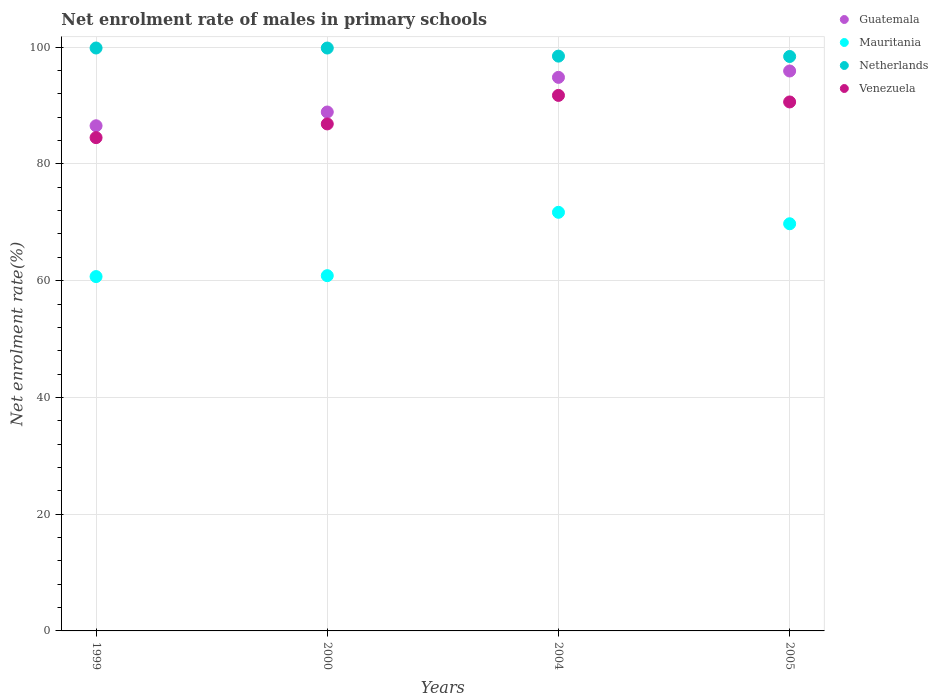What is the net enrolment rate of males in primary schools in Mauritania in 2004?
Ensure brevity in your answer.  71.71. Across all years, what is the maximum net enrolment rate of males in primary schools in Netherlands?
Ensure brevity in your answer.  99.86. Across all years, what is the minimum net enrolment rate of males in primary schools in Mauritania?
Your answer should be very brief. 60.7. In which year was the net enrolment rate of males in primary schools in Netherlands minimum?
Your answer should be very brief. 2005. What is the total net enrolment rate of males in primary schools in Netherlands in the graph?
Give a very brief answer. 396.6. What is the difference between the net enrolment rate of males in primary schools in Mauritania in 2000 and that in 2005?
Your answer should be very brief. -8.89. What is the difference between the net enrolment rate of males in primary schools in Netherlands in 2004 and the net enrolment rate of males in primary schools in Guatemala in 2000?
Provide a short and direct response. 9.57. What is the average net enrolment rate of males in primary schools in Netherlands per year?
Offer a very short reply. 99.15. In the year 2004, what is the difference between the net enrolment rate of males in primary schools in Guatemala and net enrolment rate of males in primary schools in Venezuela?
Keep it short and to the point. 3.09. What is the ratio of the net enrolment rate of males in primary schools in Mauritania in 1999 to that in 2000?
Your answer should be compact. 1. Is the difference between the net enrolment rate of males in primary schools in Guatemala in 2000 and 2005 greater than the difference between the net enrolment rate of males in primary schools in Venezuela in 2000 and 2005?
Give a very brief answer. No. What is the difference between the highest and the second highest net enrolment rate of males in primary schools in Mauritania?
Make the answer very short. 1.96. What is the difference between the highest and the lowest net enrolment rate of males in primary schools in Mauritania?
Make the answer very short. 11.01. In how many years, is the net enrolment rate of males in primary schools in Venezuela greater than the average net enrolment rate of males in primary schools in Venezuela taken over all years?
Make the answer very short. 2. Is the sum of the net enrolment rate of males in primary schools in Guatemala in 2004 and 2005 greater than the maximum net enrolment rate of males in primary schools in Venezuela across all years?
Your answer should be very brief. Yes. Is it the case that in every year, the sum of the net enrolment rate of males in primary schools in Venezuela and net enrolment rate of males in primary schools in Guatemala  is greater than the net enrolment rate of males in primary schools in Netherlands?
Offer a terse response. Yes. Is the net enrolment rate of males in primary schools in Netherlands strictly greater than the net enrolment rate of males in primary schools in Guatemala over the years?
Give a very brief answer. Yes. How many dotlines are there?
Make the answer very short. 4. What is the difference between two consecutive major ticks on the Y-axis?
Keep it short and to the point. 20. Does the graph contain any zero values?
Keep it short and to the point. No. Where does the legend appear in the graph?
Your answer should be compact. Top right. What is the title of the graph?
Provide a short and direct response. Net enrolment rate of males in primary schools. Does "High income: OECD" appear as one of the legend labels in the graph?
Provide a succinct answer. No. What is the label or title of the X-axis?
Your response must be concise. Years. What is the label or title of the Y-axis?
Your answer should be compact. Net enrolment rate(%). What is the Net enrolment rate(%) in Guatemala in 1999?
Your answer should be very brief. 86.54. What is the Net enrolment rate(%) in Mauritania in 1999?
Provide a short and direct response. 60.7. What is the Net enrolment rate(%) in Netherlands in 1999?
Your answer should be very brief. 99.86. What is the Net enrolment rate(%) in Venezuela in 1999?
Keep it short and to the point. 84.51. What is the Net enrolment rate(%) of Guatemala in 2000?
Provide a succinct answer. 88.9. What is the Net enrolment rate(%) of Mauritania in 2000?
Offer a terse response. 60.86. What is the Net enrolment rate(%) in Netherlands in 2000?
Offer a terse response. 99.86. What is the Net enrolment rate(%) of Venezuela in 2000?
Provide a short and direct response. 86.85. What is the Net enrolment rate(%) in Guatemala in 2004?
Your answer should be compact. 94.83. What is the Net enrolment rate(%) of Mauritania in 2004?
Provide a succinct answer. 71.71. What is the Net enrolment rate(%) of Netherlands in 2004?
Ensure brevity in your answer.  98.47. What is the Net enrolment rate(%) of Venezuela in 2004?
Keep it short and to the point. 91.74. What is the Net enrolment rate(%) of Guatemala in 2005?
Keep it short and to the point. 95.92. What is the Net enrolment rate(%) in Mauritania in 2005?
Provide a short and direct response. 69.75. What is the Net enrolment rate(%) in Netherlands in 2005?
Provide a succinct answer. 98.41. What is the Net enrolment rate(%) of Venezuela in 2005?
Offer a terse response. 90.62. Across all years, what is the maximum Net enrolment rate(%) of Guatemala?
Keep it short and to the point. 95.92. Across all years, what is the maximum Net enrolment rate(%) in Mauritania?
Make the answer very short. 71.71. Across all years, what is the maximum Net enrolment rate(%) in Netherlands?
Ensure brevity in your answer.  99.86. Across all years, what is the maximum Net enrolment rate(%) of Venezuela?
Offer a terse response. 91.74. Across all years, what is the minimum Net enrolment rate(%) in Guatemala?
Give a very brief answer. 86.54. Across all years, what is the minimum Net enrolment rate(%) of Mauritania?
Offer a very short reply. 60.7. Across all years, what is the minimum Net enrolment rate(%) of Netherlands?
Provide a succinct answer. 98.41. Across all years, what is the minimum Net enrolment rate(%) in Venezuela?
Provide a short and direct response. 84.51. What is the total Net enrolment rate(%) of Guatemala in the graph?
Provide a short and direct response. 366.19. What is the total Net enrolment rate(%) of Mauritania in the graph?
Make the answer very short. 263.03. What is the total Net enrolment rate(%) in Netherlands in the graph?
Give a very brief answer. 396.6. What is the total Net enrolment rate(%) in Venezuela in the graph?
Provide a short and direct response. 353.72. What is the difference between the Net enrolment rate(%) of Guatemala in 1999 and that in 2000?
Offer a terse response. -2.36. What is the difference between the Net enrolment rate(%) of Mauritania in 1999 and that in 2000?
Ensure brevity in your answer.  -0.16. What is the difference between the Net enrolment rate(%) of Netherlands in 1999 and that in 2000?
Offer a very short reply. 0. What is the difference between the Net enrolment rate(%) of Venezuela in 1999 and that in 2000?
Provide a short and direct response. -2.35. What is the difference between the Net enrolment rate(%) in Guatemala in 1999 and that in 2004?
Your answer should be compact. -8.29. What is the difference between the Net enrolment rate(%) in Mauritania in 1999 and that in 2004?
Offer a very short reply. -11.01. What is the difference between the Net enrolment rate(%) of Netherlands in 1999 and that in 2004?
Your response must be concise. 1.39. What is the difference between the Net enrolment rate(%) of Venezuela in 1999 and that in 2004?
Offer a terse response. -7.23. What is the difference between the Net enrolment rate(%) in Guatemala in 1999 and that in 2005?
Offer a terse response. -9.38. What is the difference between the Net enrolment rate(%) in Mauritania in 1999 and that in 2005?
Keep it short and to the point. -9.05. What is the difference between the Net enrolment rate(%) in Netherlands in 1999 and that in 2005?
Keep it short and to the point. 1.45. What is the difference between the Net enrolment rate(%) of Venezuela in 1999 and that in 2005?
Your response must be concise. -6.11. What is the difference between the Net enrolment rate(%) of Guatemala in 2000 and that in 2004?
Offer a terse response. -5.94. What is the difference between the Net enrolment rate(%) of Mauritania in 2000 and that in 2004?
Your answer should be compact. -10.85. What is the difference between the Net enrolment rate(%) in Netherlands in 2000 and that in 2004?
Offer a very short reply. 1.39. What is the difference between the Net enrolment rate(%) in Venezuela in 2000 and that in 2004?
Your answer should be very brief. -4.89. What is the difference between the Net enrolment rate(%) of Guatemala in 2000 and that in 2005?
Offer a terse response. -7.03. What is the difference between the Net enrolment rate(%) in Mauritania in 2000 and that in 2005?
Provide a succinct answer. -8.89. What is the difference between the Net enrolment rate(%) of Netherlands in 2000 and that in 2005?
Provide a short and direct response. 1.45. What is the difference between the Net enrolment rate(%) of Venezuela in 2000 and that in 2005?
Make the answer very short. -3.76. What is the difference between the Net enrolment rate(%) of Guatemala in 2004 and that in 2005?
Provide a short and direct response. -1.09. What is the difference between the Net enrolment rate(%) in Mauritania in 2004 and that in 2005?
Give a very brief answer. 1.96. What is the difference between the Net enrolment rate(%) in Netherlands in 2004 and that in 2005?
Your answer should be very brief. 0.06. What is the difference between the Net enrolment rate(%) in Venezuela in 2004 and that in 2005?
Your answer should be compact. 1.12. What is the difference between the Net enrolment rate(%) in Guatemala in 1999 and the Net enrolment rate(%) in Mauritania in 2000?
Provide a short and direct response. 25.68. What is the difference between the Net enrolment rate(%) of Guatemala in 1999 and the Net enrolment rate(%) of Netherlands in 2000?
Your response must be concise. -13.32. What is the difference between the Net enrolment rate(%) of Guatemala in 1999 and the Net enrolment rate(%) of Venezuela in 2000?
Your response must be concise. -0.31. What is the difference between the Net enrolment rate(%) in Mauritania in 1999 and the Net enrolment rate(%) in Netherlands in 2000?
Give a very brief answer. -39.15. What is the difference between the Net enrolment rate(%) in Mauritania in 1999 and the Net enrolment rate(%) in Venezuela in 2000?
Your answer should be compact. -26.15. What is the difference between the Net enrolment rate(%) in Netherlands in 1999 and the Net enrolment rate(%) in Venezuela in 2000?
Your response must be concise. 13.01. What is the difference between the Net enrolment rate(%) of Guatemala in 1999 and the Net enrolment rate(%) of Mauritania in 2004?
Your response must be concise. 14.83. What is the difference between the Net enrolment rate(%) of Guatemala in 1999 and the Net enrolment rate(%) of Netherlands in 2004?
Give a very brief answer. -11.93. What is the difference between the Net enrolment rate(%) of Guatemala in 1999 and the Net enrolment rate(%) of Venezuela in 2004?
Provide a succinct answer. -5.2. What is the difference between the Net enrolment rate(%) in Mauritania in 1999 and the Net enrolment rate(%) in Netherlands in 2004?
Offer a very short reply. -37.77. What is the difference between the Net enrolment rate(%) of Mauritania in 1999 and the Net enrolment rate(%) of Venezuela in 2004?
Offer a terse response. -31.04. What is the difference between the Net enrolment rate(%) of Netherlands in 1999 and the Net enrolment rate(%) of Venezuela in 2004?
Offer a very short reply. 8.12. What is the difference between the Net enrolment rate(%) in Guatemala in 1999 and the Net enrolment rate(%) in Mauritania in 2005?
Provide a succinct answer. 16.79. What is the difference between the Net enrolment rate(%) in Guatemala in 1999 and the Net enrolment rate(%) in Netherlands in 2005?
Offer a very short reply. -11.87. What is the difference between the Net enrolment rate(%) in Guatemala in 1999 and the Net enrolment rate(%) in Venezuela in 2005?
Your response must be concise. -4.08. What is the difference between the Net enrolment rate(%) in Mauritania in 1999 and the Net enrolment rate(%) in Netherlands in 2005?
Give a very brief answer. -37.71. What is the difference between the Net enrolment rate(%) in Mauritania in 1999 and the Net enrolment rate(%) in Venezuela in 2005?
Offer a very short reply. -29.92. What is the difference between the Net enrolment rate(%) of Netherlands in 1999 and the Net enrolment rate(%) of Venezuela in 2005?
Provide a succinct answer. 9.24. What is the difference between the Net enrolment rate(%) of Guatemala in 2000 and the Net enrolment rate(%) of Mauritania in 2004?
Provide a short and direct response. 17.18. What is the difference between the Net enrolment rate(%) in Guatemala in 2000 and the Net enrolment rate(%) in Netherlands in 2004?
Offer a very short reply. -9.57. What is the difference between the Net enrolment rate(%) in Guatemala in 2000 and the Net enrolment rate(%) in Venezuela in 2004?
Ensure brevity in your answer.  -2.84. What is the difference between the Net enrolment rate(%) of Mauritania in 2000 and the Net enrolment rate(%) of Netherlands in 2004?
Provide a succinct answer. -37.61. What is the difference between the Net enrolment rate(%) in Mauritania in 2000 and the Net enrolment rate(%) in Venezuela in 2004?
Your answer should be compact. -30.88. What is the difference between the Net enrolment rate(%) of Netherlands in 2000 and the Net enrolment rate(%) of Venezuela in 2004?
Your answer should be very brief. 8.12. What is the difference between the Net enrolment rate(%) of Guatemala in 2000 and the Net enrolment rate(%) of Mauritania in 2005?
Your answer should be compact. 19.14. What is the difference between the Net enrolment rate(%) of Guatemala in 2000 and the Net enrolment rate(%) of Netherlands in 2005?
Give a very brief answer. -9.51. What is the difference between the Net enrolment rate(%) of Guatemala in 2000 and the Net enrolment rate(%) of Venezuela in 2005?
Offer a very short reply. -1.72. What is the difference between the Net enrolment rate(%) of Mauritania in 2000 and the Net enrolment rate(%) of Netherlands in 2005?
Provide a short and direct response. -37.55. What is the difference between the Net enrolment rate(%) in Mauritania in 2000 and the Net enrolment rate(%) in Venezuela in 2005?
Your response must be concise. -29.76. What is the difference between the Net enrolment rate(%) in Netherlands in 2000 and the Net enrolment rate(%) in Venezuela in 2005?
Ensure brevity in your answer.  9.24. What is the difference between the Net enrolment rate(%) in Guatemala in 2004 and the Net enrolment rate(%) in Mauritania in 2005?
Ensure brevity in your answer.  25.08. What is the difference between the Net enrolment rate(%) in Guatemala in 2004 and the Net enrolment rate(%) in Netherlands in 2005?
Your answer should be very brief. -3.58. What is the difference between the Net enrolment rate(%) of Guatemala in 2004 and the Net enrolment rate(%) of Venezuela in 2005?
Your answer should be very brief. 4.21. What is the difference between the Net enrolment rate(%) in Mauritania in 2004 and the Net enrolment rate(%) in Netherlands in 2005?
Make the answer very short. -26.7. What is the difference between the Net enrolment rate(%) of Mauritania in 2004 and the Net enrolment rate(%) of Venezuela in 2005?
Your answer should be very brief. -18.91. What is the difference between the Net enrolment rate(%) of Netherlands in 2004 and the Net enrolment rate(%) of Venezuela in 2005?
Make the answer very short. 7.85. What is the average Net enrolment rate(%) of Guatemala per year?
Your answer should be very brief. 91.55. What is the average Net enrolment rate(%) of Mauritania per year?
Ensure brevity in your answer.  65.76. What is the average Net enrolment rate(%) in Netherlands per year?
Provide a succinct answer. 99.15. What is the average Net enrolment rate(%) in Venezuela per year?
Your response must be concise. 88.43. In the year 1999, what is the difference between the Net enrolment rate(%) in Guatemala and Net enrolment rate(%) in Mauritania?
Keep it short and to the point. 25.84. In the year 1999, what is the difference between the Net enrolment rate(%) of Guatemala and Net enrolment rate(%) of Netherlands?
Ensure brevity in your answer.  -13.32. In the year 1999, what is the difference between the Net enrolment rate(%) of Guatemala and Net enrolment rate(%) of Venezuela?
Ensure brevity in your answer.  2.03. In the year 1999, what is the difference between the Net enrolment rate(%) in Mauritania and Net enrolment rate(%) in Netherlands?
Ensure brevity in your answer.  -39.16. In the year 1999, what is the difference between the Net enrolment rate(%) in Mauritania and Net enrolment rate(%) in Venezuela?
Give a very brief answer. -23.8. In the year 1999, what is the difference between the Net enrolment rate(%) of Netherlands and Net enrolment rate(%) of Venezuela?
Your answer should be compact. 15.36. In the year 2000, what is the difference between the Net enrolment rate(%) of Guatemala and Net enrolment rate(%) of Mauritania?
Offer a very short reply. 28.04. In the year 2000, what is the difference between the Net enrolment rate(%) of Guatemala and Net enrolment rate(%) of Netherlands?
Offer a terse response. -10.96. In the year 2000, what is the difference between the Net enrolment rate(%) in Guatemala and Net enrolment rate(%) in Venezuela?
Offer a terse response. 2.04. In the year 2000, what is the difference between the Net enrolment rate(%) of Mauritania and Net enrolment rate(%) of Netherlands?
Offer a very short reply. -39. In the year 2000, what is the difference between the Net enrolment rate(%) in Mauritania and Net enrolment rate(%) in Venezuela?
Your response must be concise. -25.99. In the year 2000, what is the difference between the Net enrolment rate(%) of Netherlands and Net enrolment rate(%) of Venezuela?
Your answer should be very brief. 13. In the year 2004, what is the difference between the Net enrolment rate(%) of Guatemala and Net enrolment rate(%) of Mauritania?
Make the answer very short. 23.12. In the year 2004, what is the difference between the Net enrolment rate(%) of Guatemala and Net enrolment rate(%) of Netherlands?
Your response must be concise. -3.64. In the year 2004, what is the difference between the Net enrolment rate(%) in Guatemala and Net enrolment rate(%) in Venezuela?
Provide a succinct answer. 3.09. In the year 2004, what is the difference between the Net enrolment rate(%) in Mauritania and Net enrolment rate(%) in Netherlands?
Keep it short and to the point. -26.76. In the year 2004, what is the difference between the Net enrolment rate(%) in Mauritania and Net enrolment rate(%) in Venezuela?
Offer a very short reply. -20.03. In the year 2004, what is the difference between the Net enrolment rate(%) of Netherlands and Net enrolment rate(%) of Venezuela?
Give a very brief answer. 6.73. In the year 2005, what is the difference between the Net enrolment rate(%) of Guatemala and Net enrolment rate(%) of Mauritania?
Keep it short and to the point. 26.17. In the year 2005, what is the difference between the Net enrolment rate(%) in Guatemala and Net enrolment rate(%) in Netherlands?
Your response must be concise. -2.48. In the year 2005, what is the difference between the Net enrolment rate(%) in Guatemala and Net enrolment rate(%) in Venezuela?
Provide a short and direct response. 5.3. In the year 2005, what is the difference between the Net enrolment rate(%) in Mauritania and Net enrolment rate(%) in Netherlands?
Make the answer very short. -28.66. In the year 2005, what is the difference between the Net enrolment rate(%) of Mauritania and Net enrolment rate(%) of Venezuela?
Provide a short and direct response. -20.87. In the year 2005, what is the difference between the Net enrolment rate(%) in Netherlands and Net enrolment rate(%) in Venezuela?
Your response must be concise. 7.79. What is the ratio of the Net enrolment rate(%) in Guatemala in 1999 to that in 2000?
Your answer should be very brief. 0.97. What is the ratio of the Net enrolment rate(%) in Guatemala in 1999 to that in 2004?
Your answer should be very brief. 0.91. What is the ratio of the Net enrolment rate(%) in Mauritania in 1999 to that in 2004?
Provide a short and direct response. 0.85. What is the ratio of the Net enrolment rate(%) of Netherlands in 1999 to that in 2004?
Your answer should be very brief. 1.01. What is the ratio of the Net enrolment rate(%) in Venezuela in 1999 to that in 2004?
Keep it short and to the point. 0.92. What is the ratio of the Net enrolment rate(%) in Guatemala in 1999 to that in 2005?
Your answer should be very brief. 0.9. What is the ratio of the Net enrolment rate(%) of Mauritania in 1999 to that in 2005?
Provide a succinct answer. 0.87. What is the ratio of the Net enrolment rate(%) of Netherlands in 1999 to that in 2005?
Provide a short and direct response. 1.01. What is the ratio of the Net enrolment rate(%) of Venezuela in 1999 to that in 2005?
Offer a terse response. 0.93. What is the ratio of the Net enrolment rate(%) of Guatemala in 2000 to that in 2004?
Keep it short and to the point. 0.94. What is the ratio of the Net enrolment rate(%) of Mauritania in 2000 to that in 2004?
Your response must be concise. 0.85. What is the ratio of the Net enrolment rate(%) of Netherlands in 2000 to that in 2004?
Your answer should be compact. 1.01. What is the ratio of the Net enrolment rate(%) of Venezuela in 2000 to that in 2004?
Give a very brief answer. 0.95. What is the ratio of the Net enrolment rate(%) in Guatemala in 2000 to that in 2005?
Make the answer very short. 0.93. What is the ratio of the Net enrolment rate(%) of Mauritania in 2000 to that in 2005?
Your response must be concise. 0.87. What is the ratio of the Net enrolment rate(%) of Netherlands in 2000 to that in 2005?
Provide a succinct answer. 1.01. What is the ratio of the Net enrolment rate(%) in Venezuela in 2000 to that in 2005?
Provide a succinct answer. 0.96. What is the ratio of the Net enrolment rate(%) in Guatemala in 2004 to that in 2005?
Your answer should be compact. 0.99. What is the ratio of the Net enrolment rate(%) of Mauritania in 2004 to that in 2005?
Ensure brevity in your answer.  1.03. What is the ratio of the Net enrolment rate(%) in Netherlands in 2004 to that in 2005?
Make the answer very short. 1. What is the ratio of the Net enrolment rate(%) in Venezuela in 2004 to that in 2005?
Your answer should be very brief. 1.01. What is the difference between the highest and the second highest Net enrolment rate(%) of Guatemala?
Make the answer very short. 1.09. What is the difference between the highest and the second highest Net enrolment rate(%) of Mauritania?
Your answer should be very brief. 1.96. What is the difference between the highest and the second highest Net enrolment rate(%) of Netherlands?
Offer a very short reply. 0. What is the difference between the highest and the second highest Net enrolment rate(%) of Venezuela?
Keep it short and to the point. 1.12. What is the difference between the highest and the lowest Net enrolment rate(%) in Guatemala?
Offer a terse response. 9.38. What is the difference between the highest and the lowest Net enrolment rate(%) in Mauritania?
Offer a very short reply. 11.01. What is the difference between the highest and the lowest Net enrolment rate(%) in Netherlands?
Offer a very short reply. 1.45. What is the difference between the highest and the lowest Net enrolment rate(%) of Venezuela?
Provide a succinct answer. 7.23. 